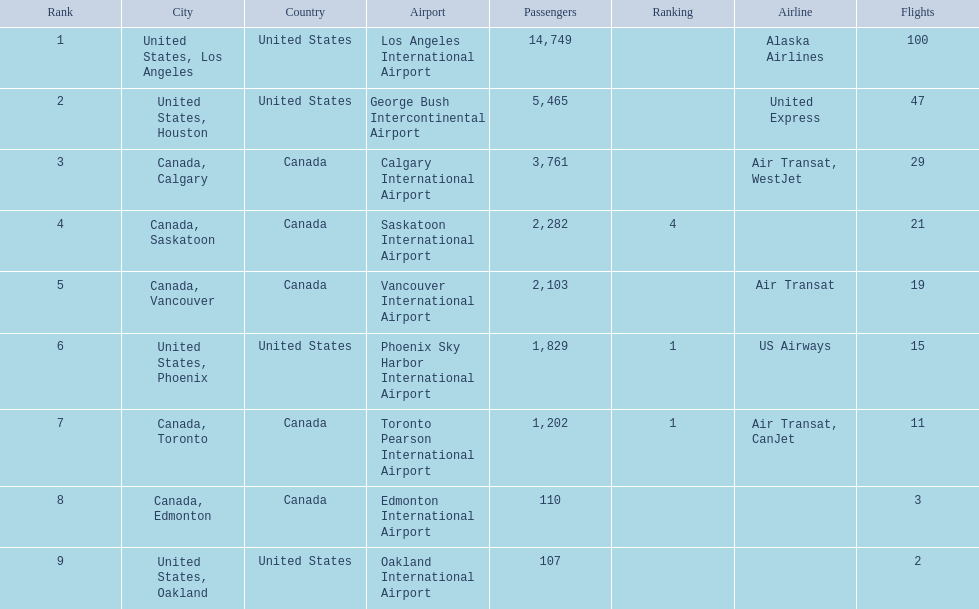What are the cities flown to? United States, Los Angeles, United States, Houston, Canada, Calgary, Canada, Saskatoon, Canada, Vancouver, United States, Phoenix, Canada, Toronto, Canada, Edmonton, United States, Oakland. What number of passengers did pheonix have? 1,829. 